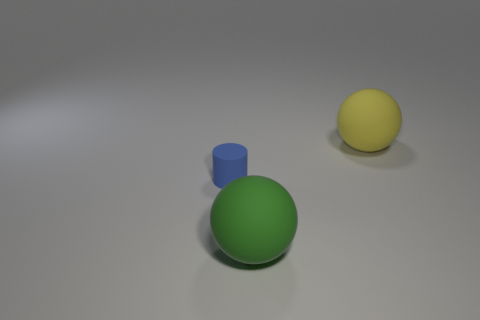What number of matte balls are behind the blue rubber object and in front of the small blue cylinder?
Offer a very short reply. 0. How many other things are there of the same color as the tiny cylinder?
Keep it short and to the point. 0. What number of gray things are small cubes or matte objects?
Provide a succinct answer. 0. How big is the yellow matte object?
Offer a terse response. Large. How many shiny objects are either big red blocks or yellow things?
Offer a very short reply. 0. Are there fewer big blue metal blocks than large spheres?
Offer a very short reply. Yes. What number of other objects are there of the same material as the small blue thing?
Offer a very short reply. 2. The green rubber thing that is the same shape as the big yellow thing is what size?
Ensure brevity in your answer.  Large. Are the ball in front of the tiny matte thing and the big object behind the small blue cylinder made of the same material?
Provide a short and direct response. Yes. Are there fewer large rubber objects behind the big green object than big purple blocks?
Keep it short and to the point. No. 